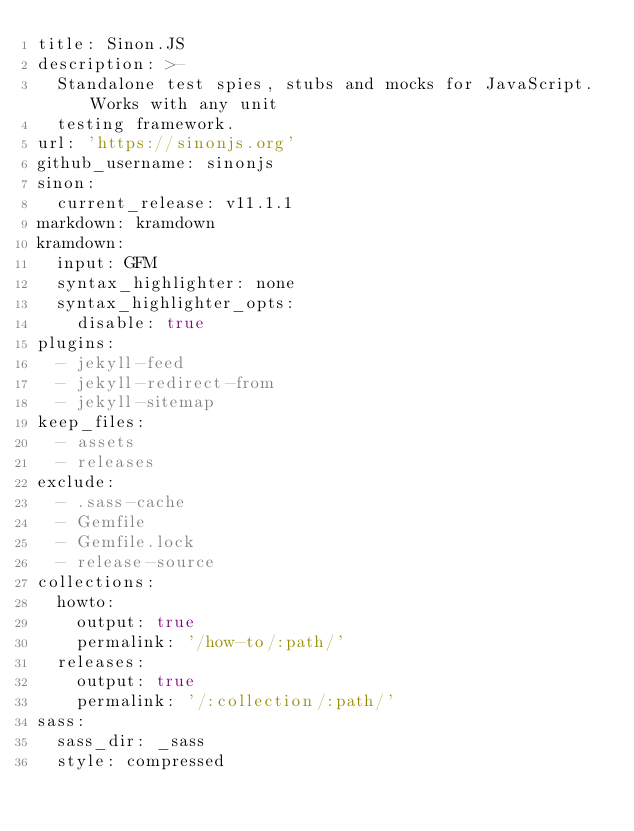<code> <loc_0><loc_0><loc_500><loc_500><_YAML_>title: Sinon.JS
description: >-
  Standalone test spies, stubs and mocks for JavaScript. Works with any unit
  testing framework.
url: 'https://sinonjs.org'
github_username: sinonjs
sinon:
  current_release: v11.1.1
markdown: kramdown
kramdown:
  input: GFM
  syntax_highlighter: none
  syntax_highlighter_opts:
    disable: true
plugins:
  - jekyll-feed
  - jekyll-redirect-from
  - jekyll-sitemap
keep_files:
  - assets
  - releases
exclude:
  - .sass-cache
  - Gemfile
  - Gemfile.lock
  - release-source
collections:
  howto:
    output: true
    permalink: '/how-to/:path/'
  releases:
    output: true
    permalink: '/:collection/:path/'
sass:
  sass_dir: _sass
  style: compressed
</code> 